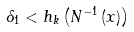<formula> <loc_0><loc_0><loc_500><loc_500>\delta _ { 1 } < h _ { k } \left ( N ^ { - 1 } \left ( x \right ) \right )</formula> 